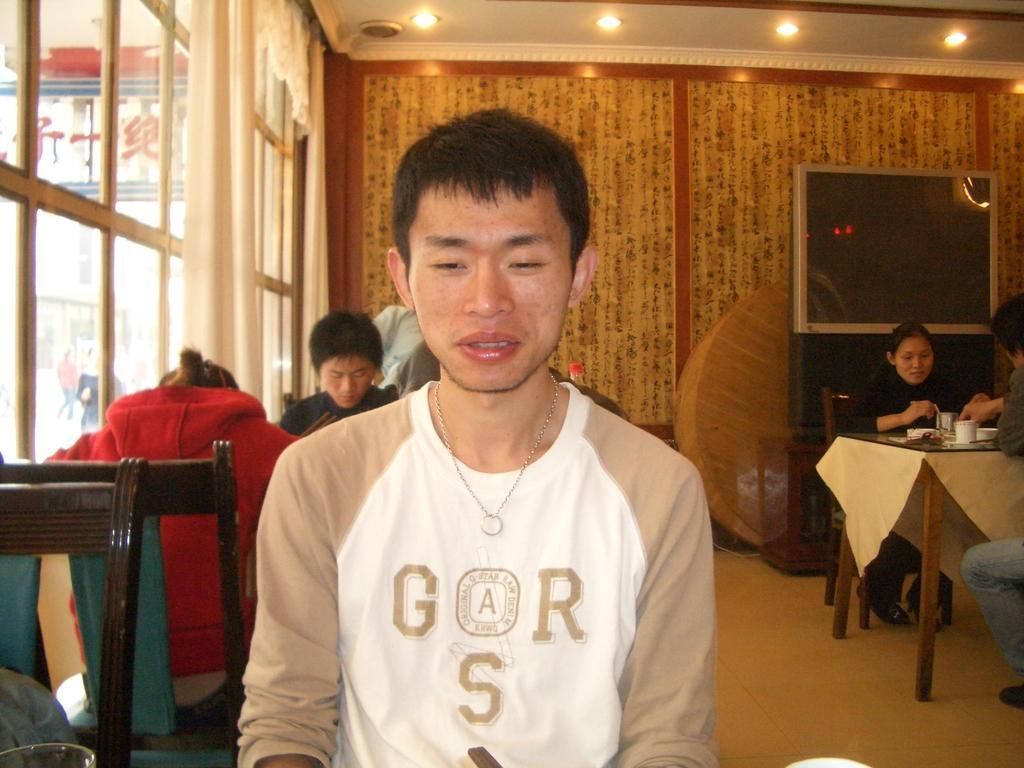In one or two sentences, can you explain what this image depicts? There are few people sitting on the chairs. This is the table covered with the cloth. There are few things on the table. This is the television. These are the ceiling lights attached to the rooftop. These are the curtains hanging. This looks like a window. 